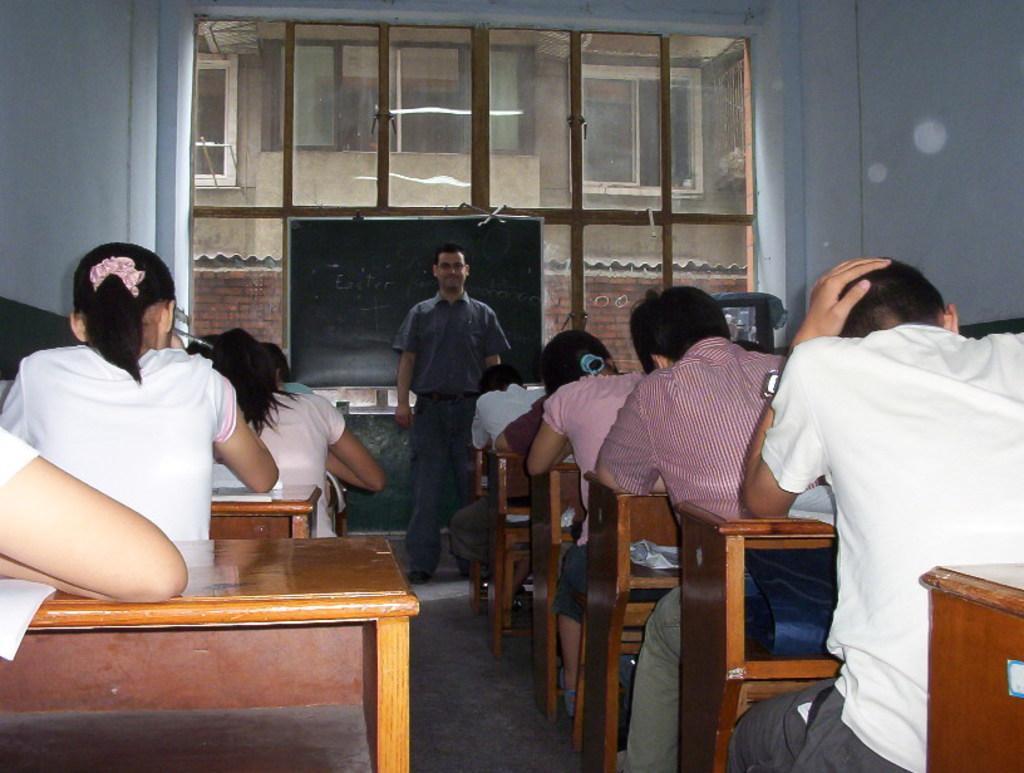Describe this image in one or two sentences. In this picture there are group of people who are sitting on the chair. There is a table. There is a blackboard. And a man is standing. At the background, there is a building. 